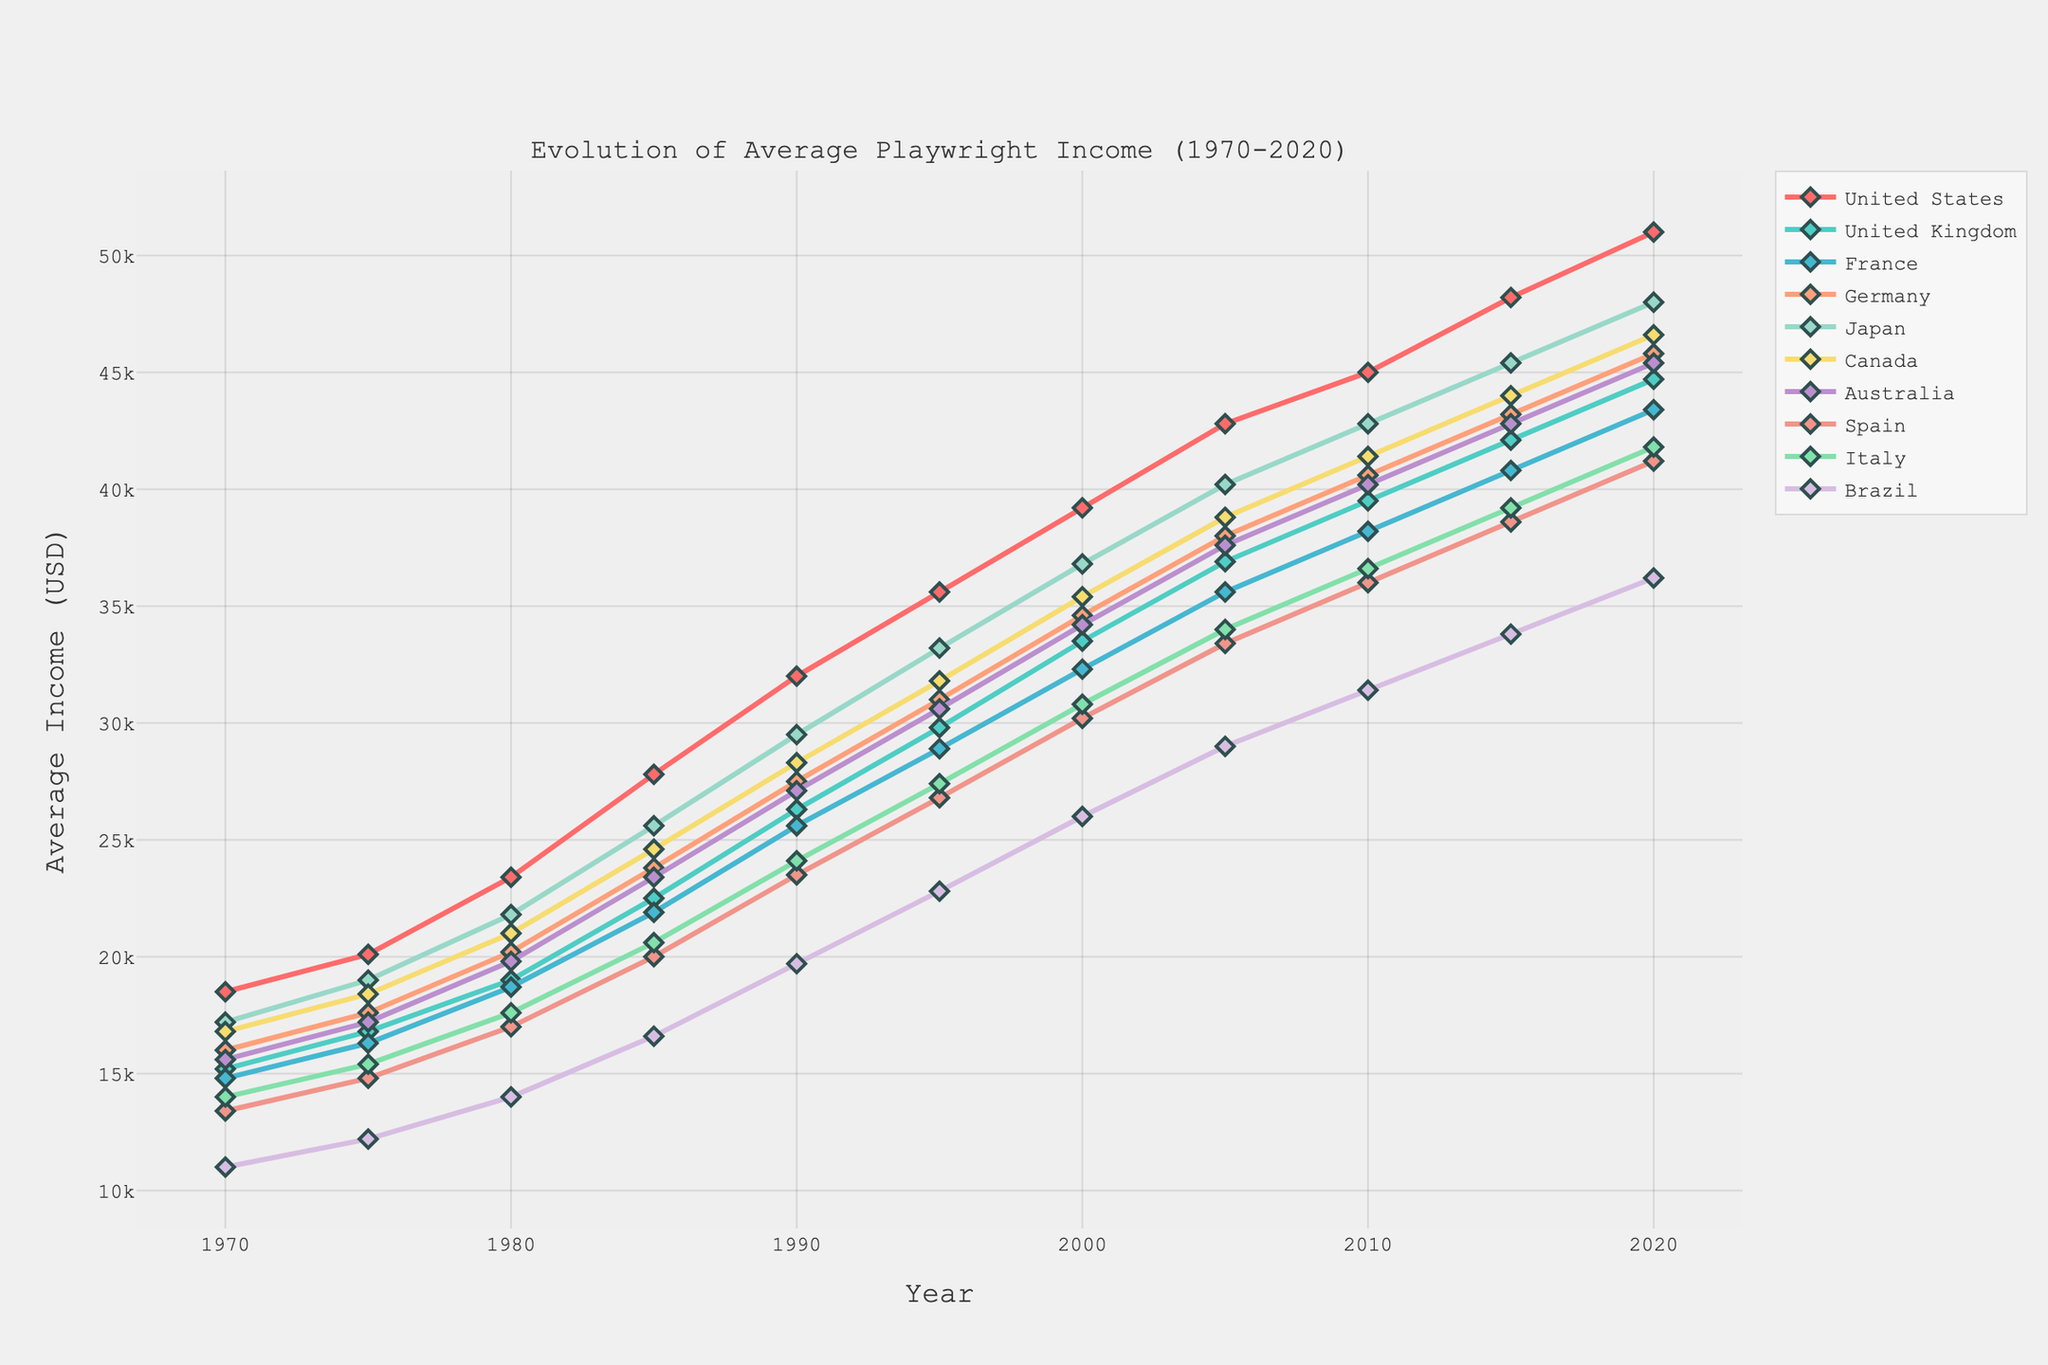Which country had the highest average playwright income in 2020? To find the country with the highest average income, we look at the values for 2020 and identify the highest one. The United States has the highest value of $51,000.
Answer: United States Which country experienced the greatest increase in average playwright income from 1970 to 2020? To find this, we calculate the difference between the 2020 and 1970 values for each country and identify the largest one. The United States had the highest increase: $51,000 - $18,500 = $32,500.
Answer: United States How much did the average income for playwrights in Spain increase from 1990 to 2000? To find the increase, subtract the 1990 average income from the 2000 average income for Spain: $30,200 - $23,500 = $6,700.
Answer: $6,700 In which year did Germany's average playwright income surpass $40,000? By inspecting the line chart for Germany, we see that the income surpasses $40,000 between 2005 and 2010. In 2010, the income is $40,600.
Answer: 2010 Compare the playwright incomes of France and Canada in 1995. Which was higher and by how much? By looking at the values for 1995 for France ($28,900) and Canada ($31,800), we find that Canada's income was higher. Subtract France's income from Canada's: $31,800 - $28,900 = $2,900.
Answer: Canada, $2,900 Which country had the smallest average playwright income in 1970? Inspecting the data for 1970, Brazil had the smallest average income: $11,000.
Answer: Brazil By how much did Japan's playwright income increase between 1985 and 2020? Subtract the 1985 value from the 2020 value for Japan: $48,000 - $25,600 = $22,400.
Answer: $22,400 Which countries had an average playwright income of more than $40,000 in 2015? We identify which countries had an income greater than $40,000 in 2015: United States ($48,200), United Kingdom ($42,100), Germany ($43,200), Japan ($45,400), and Canada ($44,000).
Answer: United States, United Kingdom, Germany, Japan, Canada What is the difference between the average playwright income of Australia and Italy in 2020? To find the difference, subtract Italy's income from Australia's income in 2020: $45,400 - $41,800 = $3,600.
Answer: $3,600 